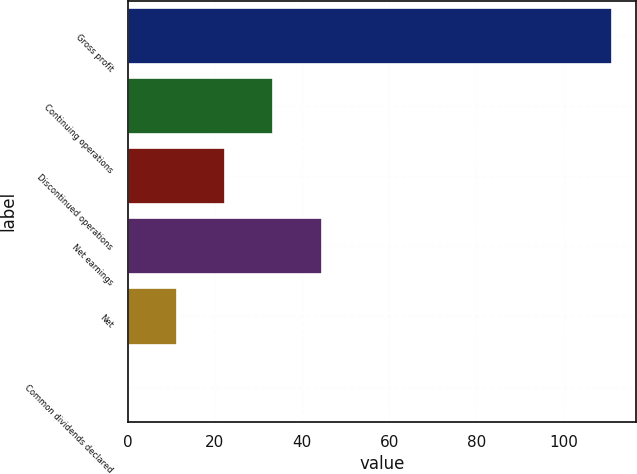Convert chart to OTSL. <chart><loc_0><loc_0><loc_500><loc_500><bar_chart><fcel>Gross profit<fcel>Continuing operations<fcel>Discontinued operations<fcel>Net earnings<fcel>Net<fcel>Common dividends declared<nl><fcel>111<fcel>33.4<fcel>22.31<fcel>44.49<fcel>11.22<fcel>0.13<nl></chart> 